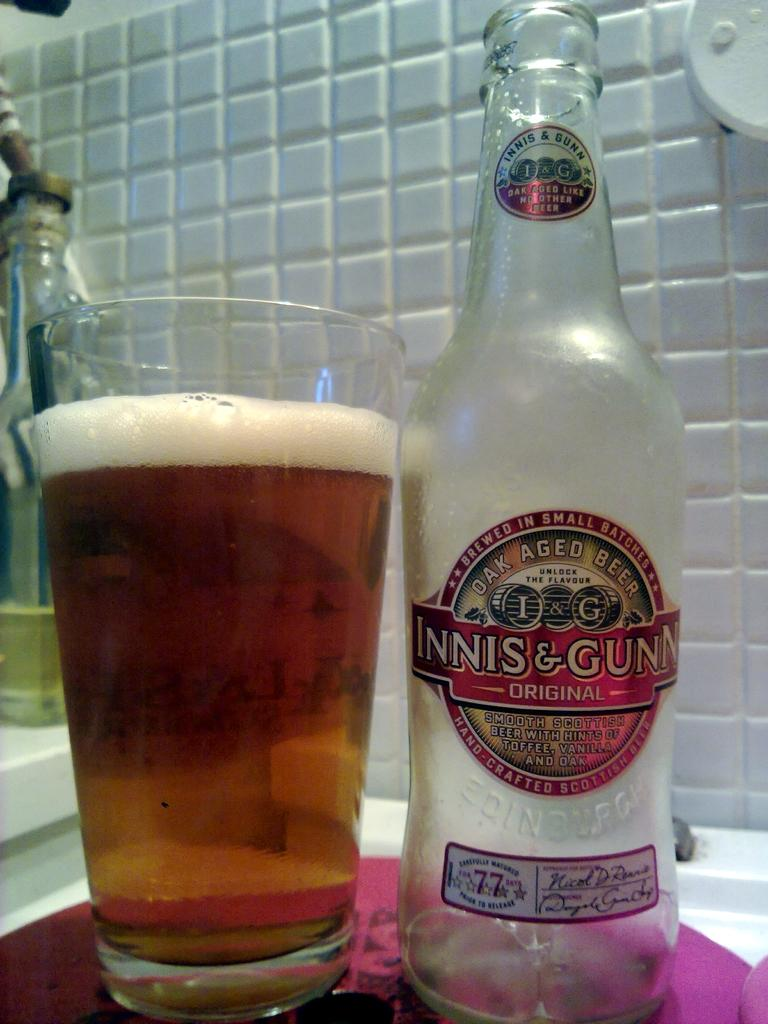<image>
Relay a brief, clear account of the picture shown. A bottle of beer emptied into a glass, the bottle says Oak Aged beer on it. 